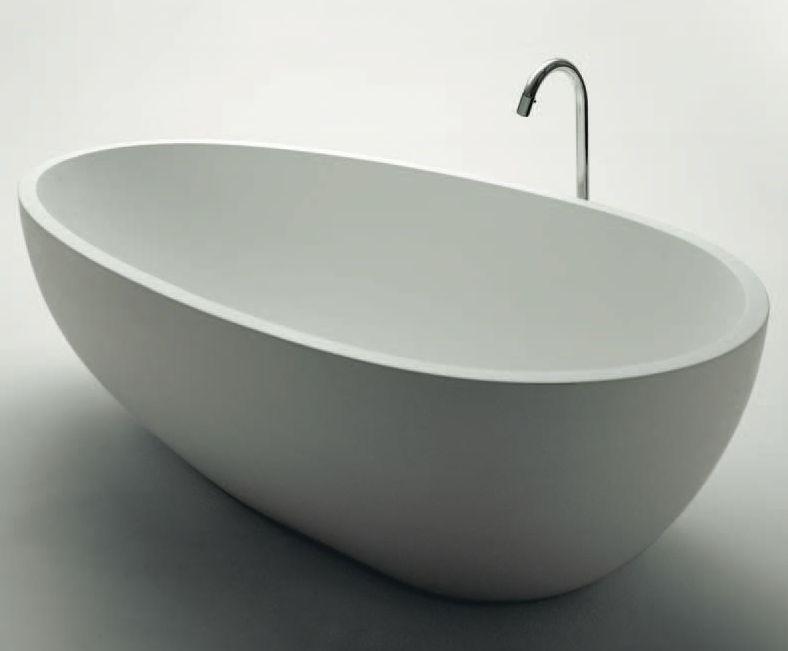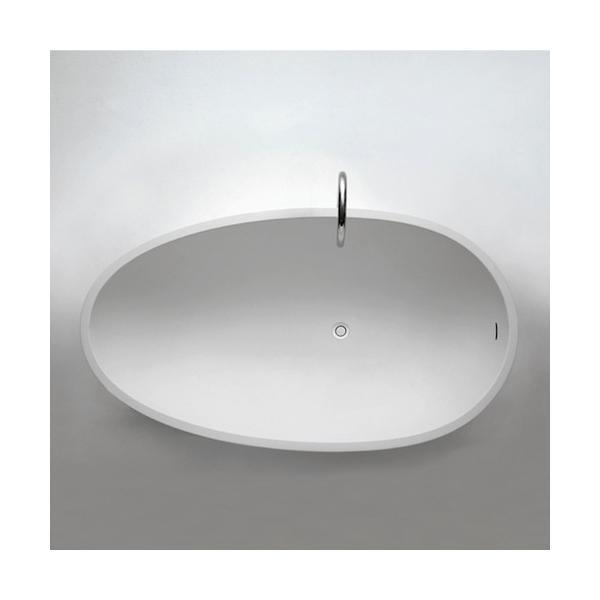The first image is the image on the left, the second image is the image on the right. Given the left and right images, does the statement "In one of the images, a bar of soap can be seen next to a sink." hold true? Answer yes or no. No. The first image is the image on the left, the second image is the image on the right. For the images shown, is this caption "There are bars of soap on the left side of a wash basin in the right image." true? Answer yes or no. No. 